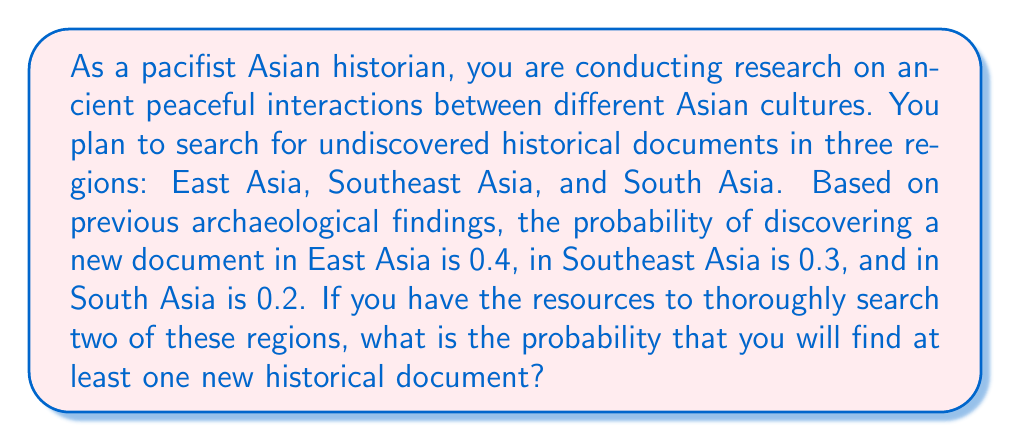Give your solution to this math problem. Let's approach this step-by-step:

1) First, we need to calculate the probability of not finding any documents in each region:
   - East Asia: $1 - 0.4 = 0.6$
   - Southeast Asia: $1 - 0.3 = 0.7$
   - South Asia: $1 - 0.2 = 0.8$

2) Now, we need to consider the probability of searching two regions. There are three possible combinations:
   a) East Asia and Southeast Asia
   b) East Asia and South Asia
   c) Southeast Asia and South Asia

3) For each combination, we calculate the probability of not finding any documents in either region:
   a) East Asia and Southeast Asia: $0.6 \times 0.7 = 0.42$
   b) East Asia and South Asia: $0.6 \times 0.8 = 0.48$
   c) Southeast Asia and South Asia: $0.7 \times 0.8 = 0.56$

4) The probability of finding at least one document is the complement of finding no documents. So for each combination:
   a) $1 - 0.42 = 0.58$
   b) $1 - 0.48 = 0.52$
   c) $1 - 0.56 = 0.44$

5) Since the question doesn't specify which two regions you'll choose, we'll take the average of these three probabilities:

   $$\frac{0.58 + 0.52 + 0.44}{3} = \frac{1.54}{3} \approx 0.5133$$

Therefore, the probability of finding at least one new historical document is approximately 0.5133 or 51.33%.
Answer: $0.5133$ or $51.33\%$ 